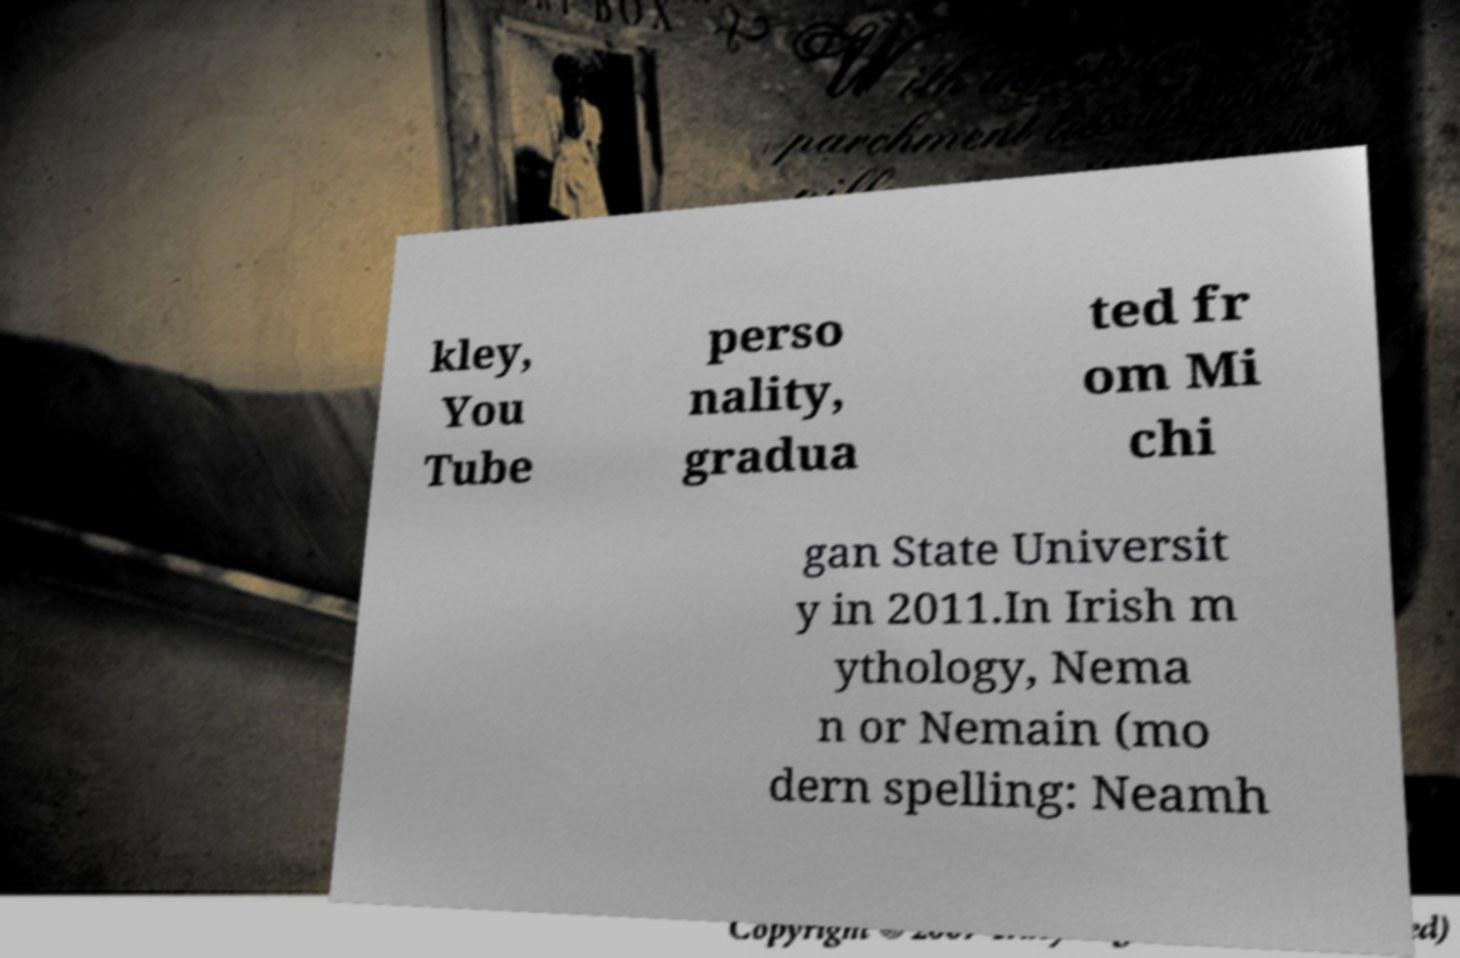Please read and relay the text visible in this image. What does it say? kley, You Tube perso nality, gradua ted fr om Mi chi gan State Universit y in 2011.In Irish m ythology, Nema n or Nemain (mo dern spelling: Neamh 